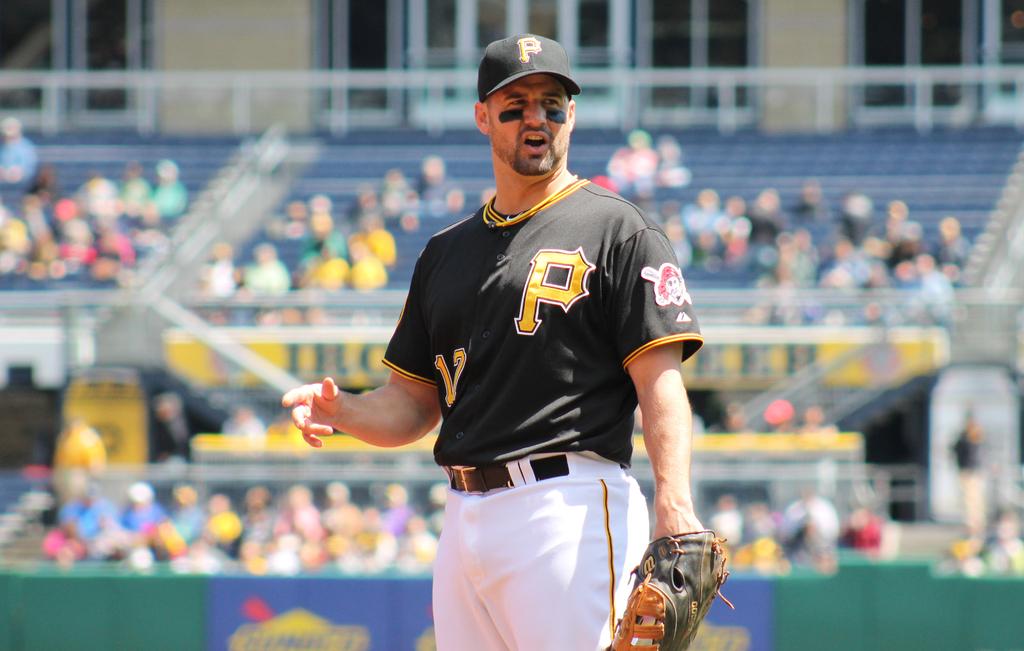What is the man sporting on his hat?
Offer a very short reply. P. 